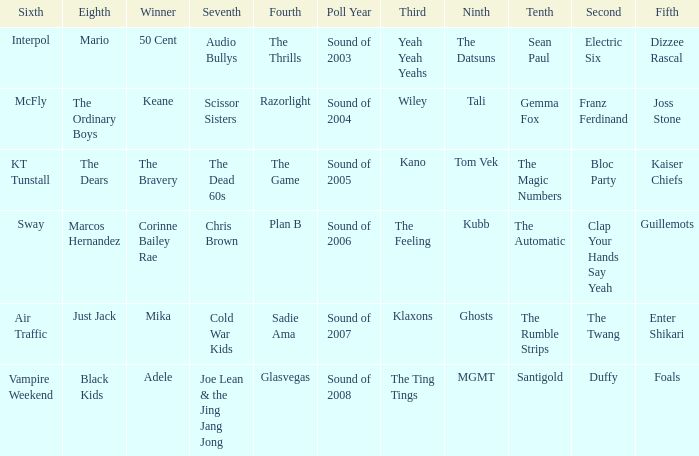When dizzee rascal is 5th, who was the winner? 50 Cent. 